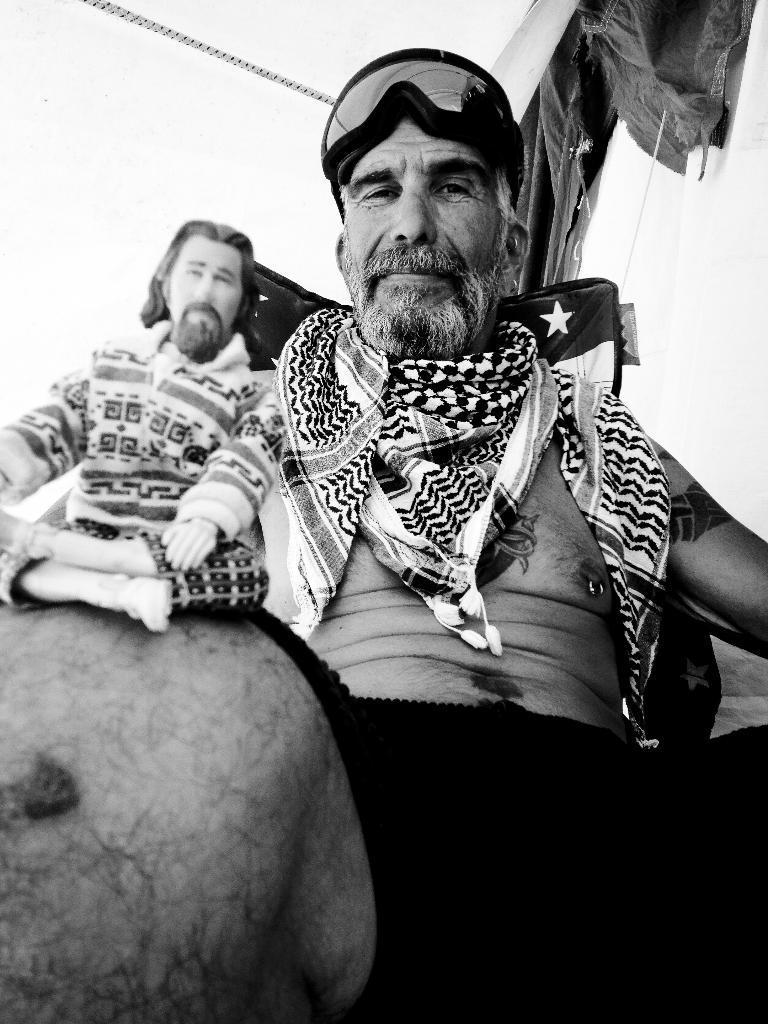Describe this image in one or two sentences. This is black and white picture were we can see two persons are sitting, one person is wearing scarf and the other one is wearing t-shirt. 